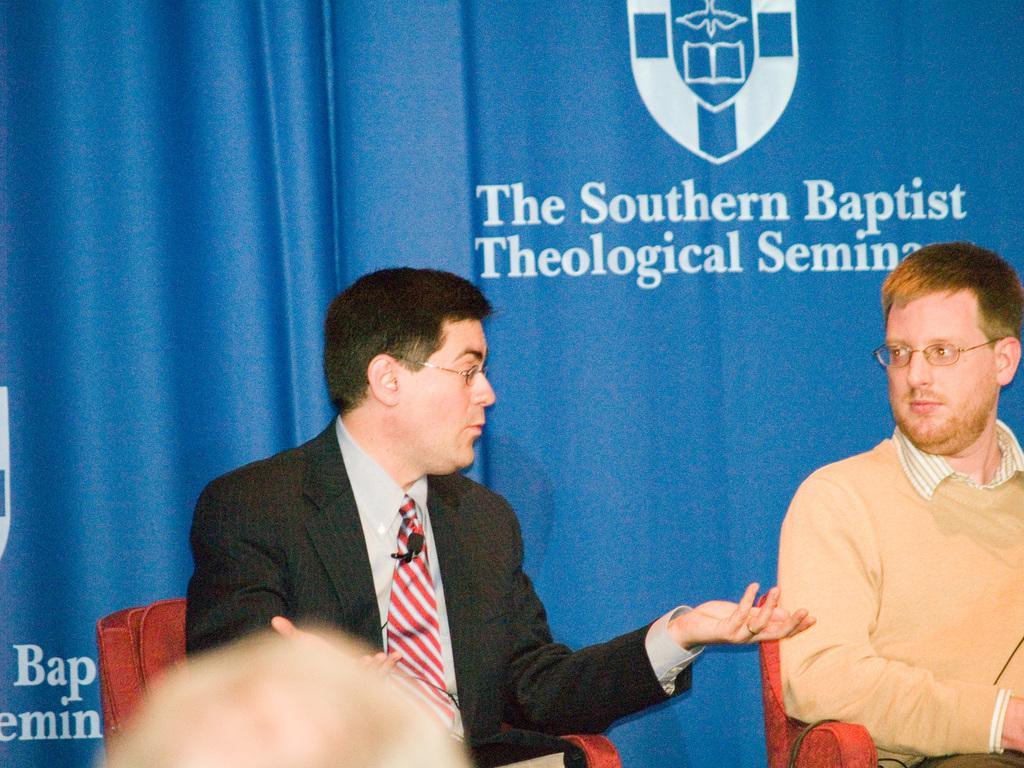Can you describe this image briefly? In this image we can see two persons are sitting on the chairs and they wore spectacles. In the background we can see a cloth and there is something written on it. 